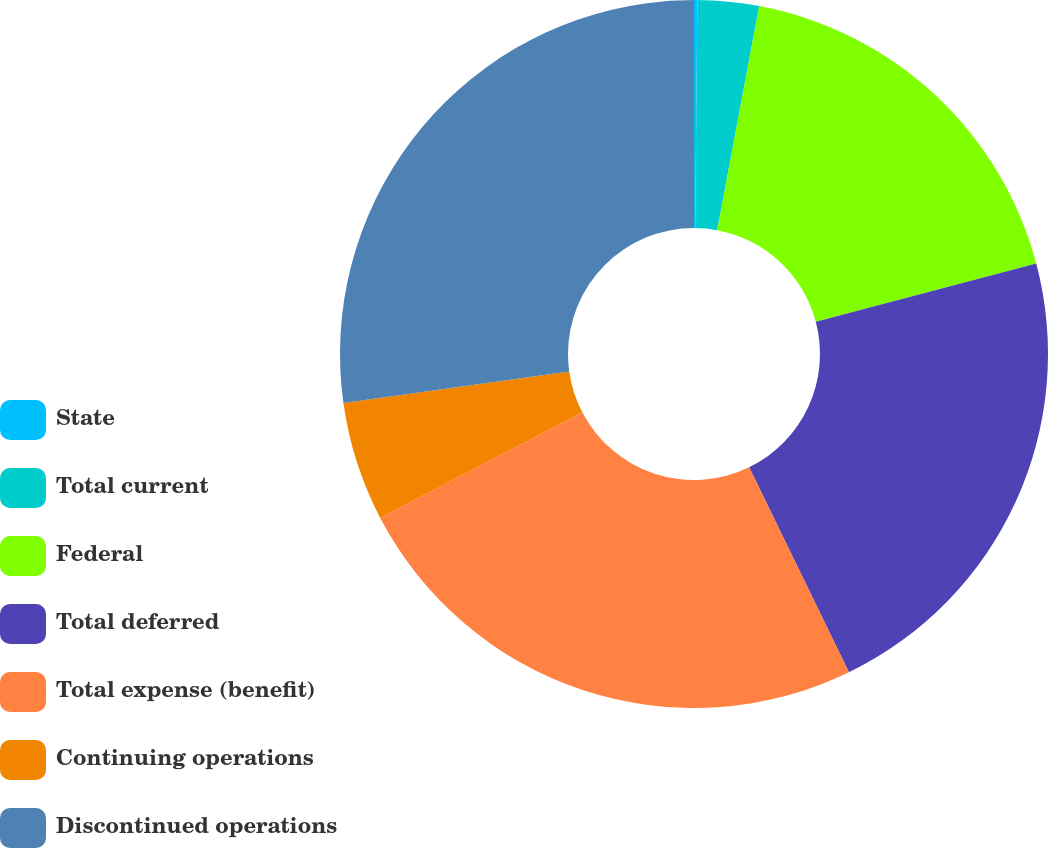Convert chart. <chart><loc_0><loc_0><loc_500><loc_500><pie_chart><fcel>State<fcel>Total current<fcel>Federal<fcel>Total deferred<fcel>Total expense (benefit)<fcel>Continuing operations<fcel>Discontinued operations<nl><fcel>0.15%<fcel>2.8%<fcel>17.94%<fcel>21.9%<fcel>24.55%<fcel>5.45%<fcel>27.21%<nl></chart> 